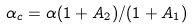<formula> <loc_0><loc_0><loc_500><loc_500>\alpha _ { c } = \alpha ( 1 + A _ { 2 } ) / ( 1 + A _ { 1 } )</formula> 